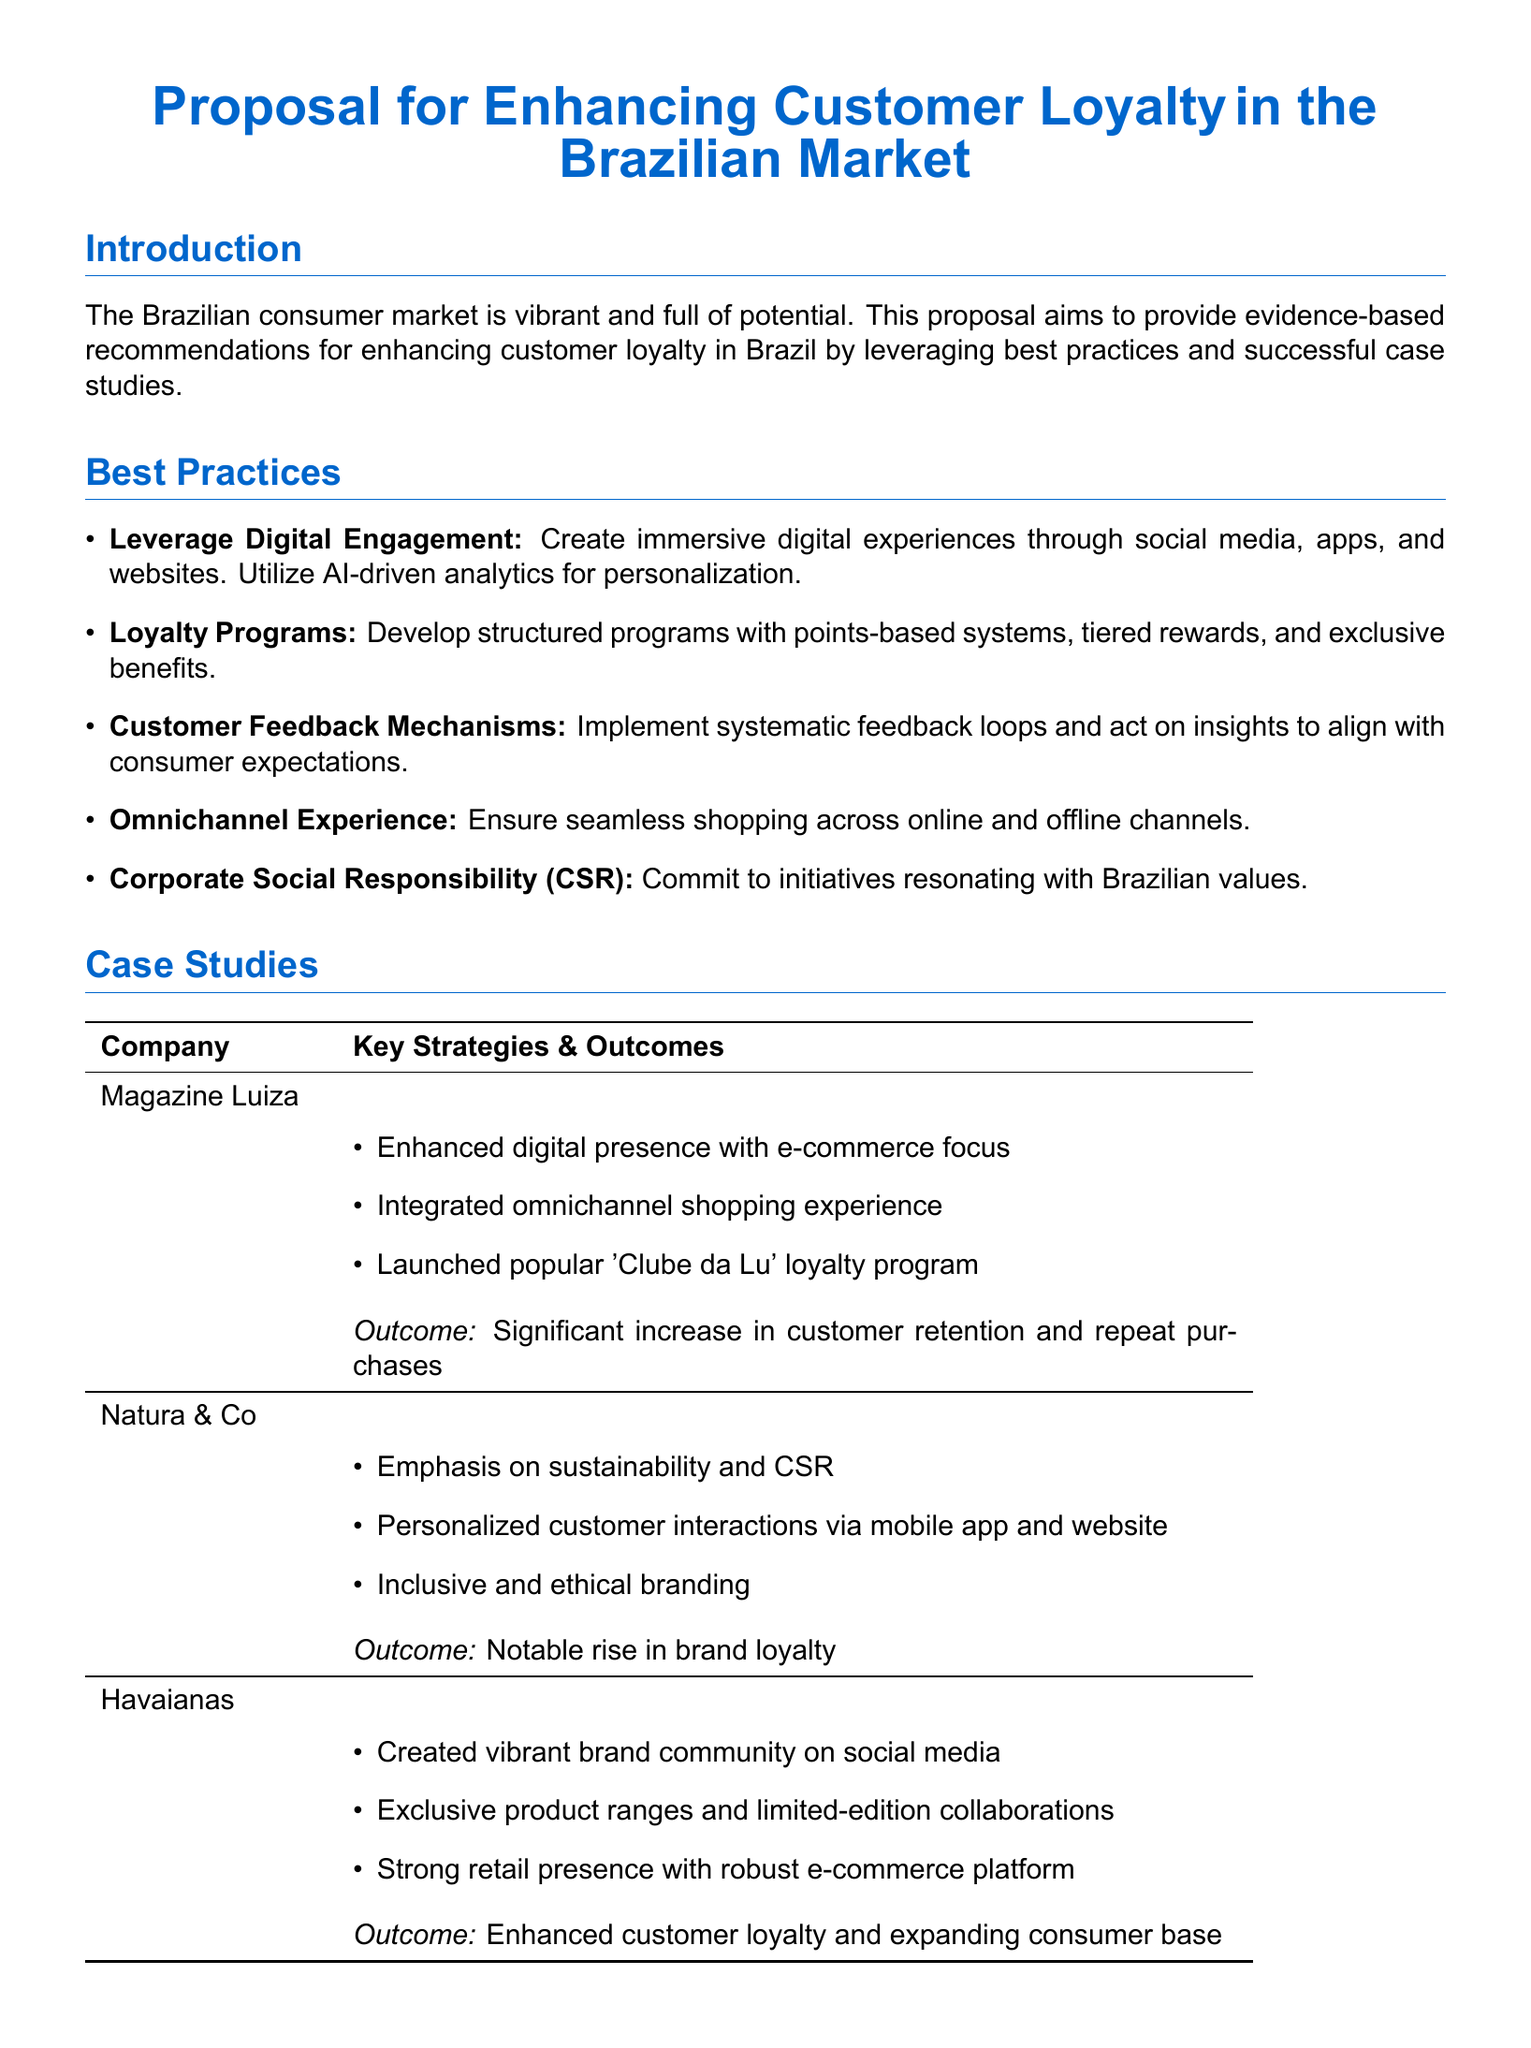What is the primary focus of the proposal? The primary focus of the proposal is to enhance customer loyalty in the Brazilian market.
Answer: Enhance customer loyalty in the Brazilian market How many case studies are presented in the document? The document features three specific case studies of companies.
Answer: Three What loyalty program is mentioned in the case study for Magazine Luiza? The loyalty program launched by Magazine Luiza is called 'Clube da Lu'.
Answer: 'Clube da Lu' Which company emphasized sustainability and CSR in their strategy? Natura & Co is highlighted for its emphasis on sustainability and CSR.
Answer: Natura & Co What type of consumer feedback mechanisms are recommended? The proposal advises implementing systematic feedback loops for consumer insights.
Answer: Systematic feedback loops What is a key strategy for Havaianas mentioned in the proposal? A key strategy for Havaianas is creating a vibrant brand community on social media.
Answer: Vibrant brand community on social media What outcome did Natura & Co achieve according to the case study? Natura & Co saw a notable rise in brand loyalty as an outcome.
Answer: Notable rise in brand loyalty What is the suggested method for providing digital experiences? The proposal suggests creating immersive digital experiences through various channels.
Answer: Immersive digital experiences What do loyalty programs include as part of their structure? Loyalty programs should include points-based systems and tiered rewards.
Answer: Points-based systems and tiered rewards 